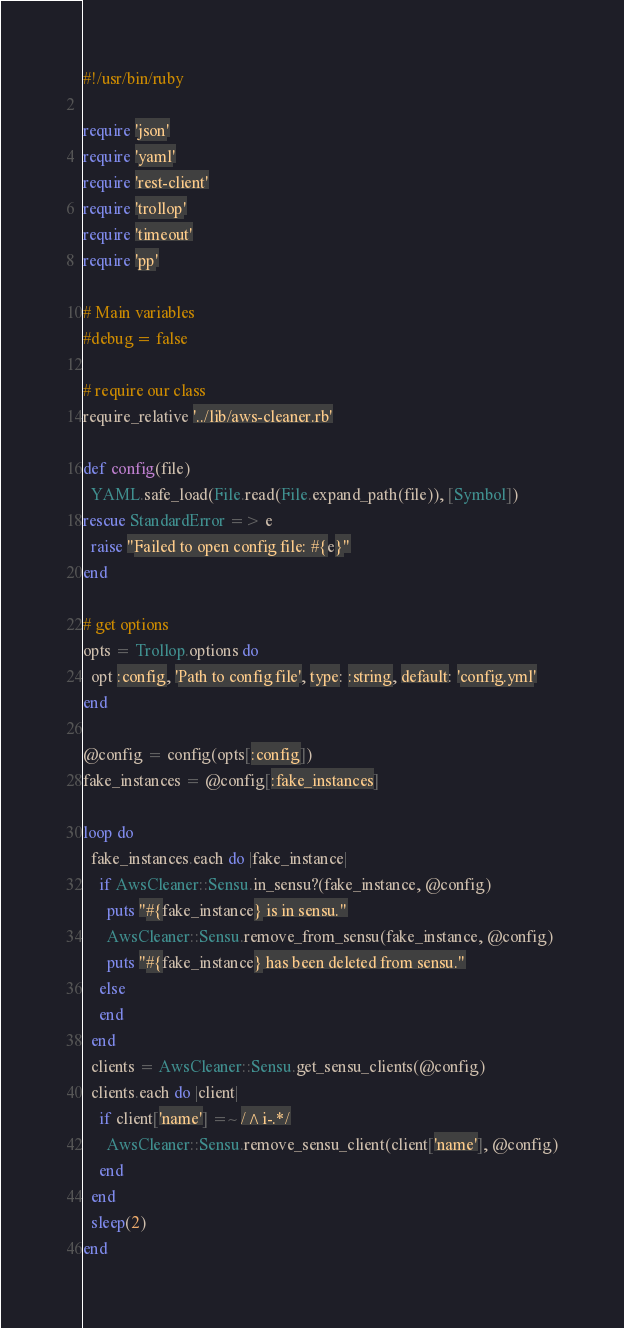<code> <loc_0><loc_0><loc_500><loc_500><_Ruby_>#!/usr/bin/ruby

require 'json'
require 'yaml'
require 'rest-client'
require 'trollop'
require 'timeout'
require 'pp'

# Main variables
#debug = false

# require our class
require_relative '../lib/aws-cleaner.rb'

def config(file)
  YAML.safe_load(File.read(File.expand_path(file)), [Symbol])
rescue StandardError => e
  raise "Failed to open config file: #{e}"
end

# get options
opts = Trollop.options do
  opt :config, 'Path to config file', type: :string, default: 'config.yml'
end

@config = config(opts[:config])
fake_instances = @config[:fake_instances]

loop do
  fake_instances.each do |fake_instance|
    if AwsCleaner::Sensu.in_sensu?(fake_instance, @config)
      puts "#{fake_instance} is in sensu."
      AwsCleaner::Sensu.remove_from_sensu(fake_instance, @config)
      puts "#{fake_instance} has been deleted from sensu."
    else
    end
  end
  clients = AwsCleaner::Sensu.get_sensu_clients(@config)
  clients.each do |client|
    if client['name'] =~ /^i-.*/
      AwsCleaner::Sensu.remove_sensu_client(client['name'], @config)
    end
  end
  sleep(2)
end
</code> 